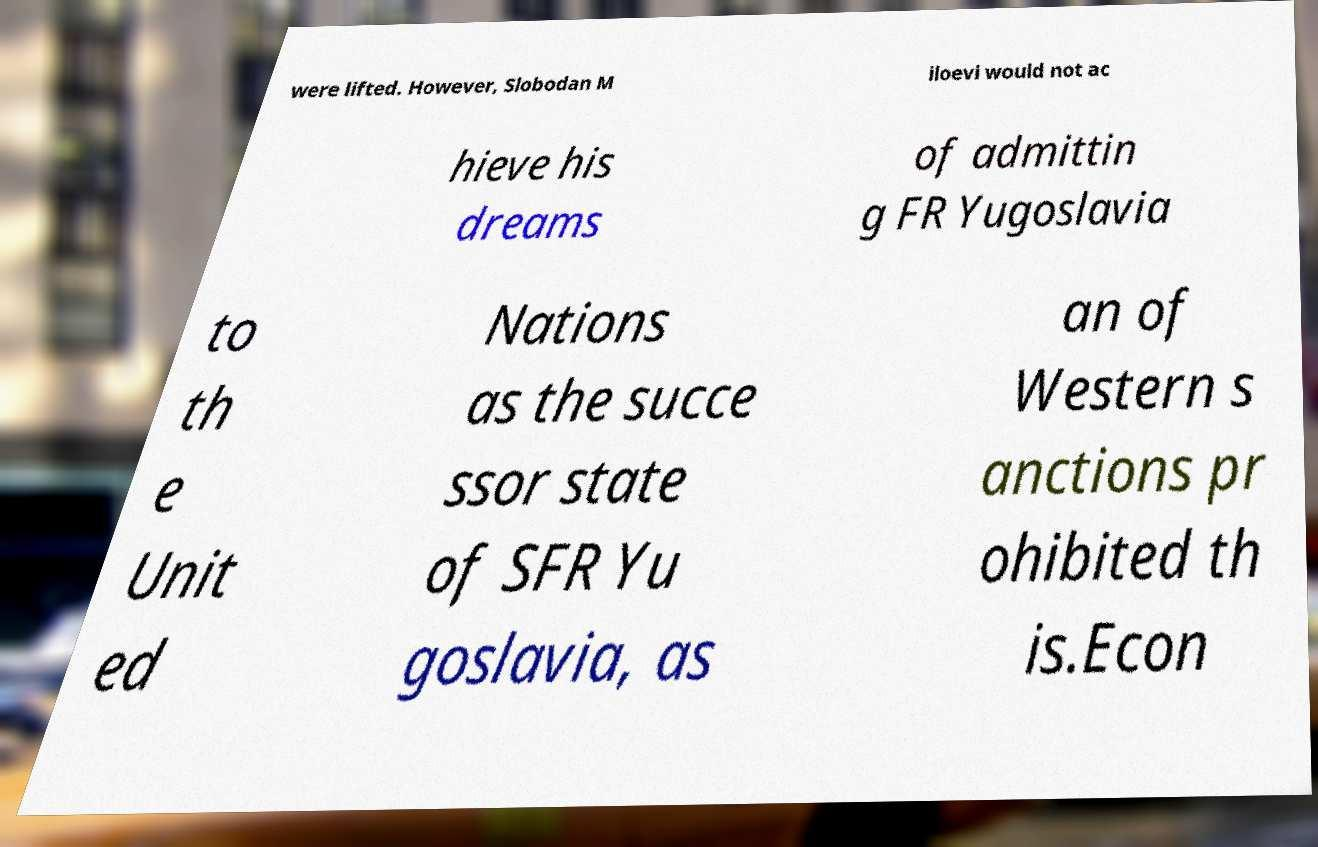Can you read and provide the text displayed in the image?This photo seems to have some interesting text. Can you extract and type it out for me? were lifted. However, Slobodan M iloevi would not ac hieve his dreams of admittin g FR Yugoslavia to th e Unit ed Nations as the succe ssor state of SFR Yu goslavia, as an of Western s anctions pr ohibited th is.Econ 